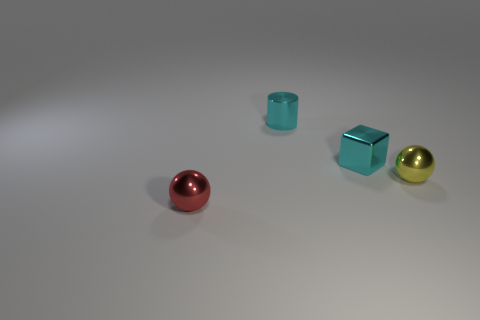There is a small shiny object that is both to the left of the tiny cube and behind the yellow sphere; what shape is it?
Keep it short and to the point. Cylinder. What size is the yellow thing that is the same shape as the small red metallic thing?
Offer a terse response. Small. What number of tiny blue balls have the same material as the small yellow sphere?
Keep it short and to the point. 0. There is a cube; does it have the same color as the small shiny cylinder behind the red object?
Provide a succinct answer. Yes. Is the number of red metallic spheres greater than the number of tiny metallic objects?
Provide a succinct answer. No. The tiny cylinder is what color?
Your answer should be very brief. Cyan. Does the object that is behind the cube have the same color as the small block?
Your response must be concise. Yes. How many shiny things have the same color as the block?
Make the answer very short. 1. There is a tiny cyan object that is on the right side of the small cyan cylinder; does it have the same shape as the yellow object?
Provide a succinct answer. No. Is the number of small yellow balls in front of the small red sphere less than the number of tiny things that are behind the tiny yellow shiny object?
Make the answer very short. Yes. 